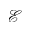Convert formula to latex. <formula><loc_0><loc_0><loc_500><loc_500>\mathcal { E }</formula> 